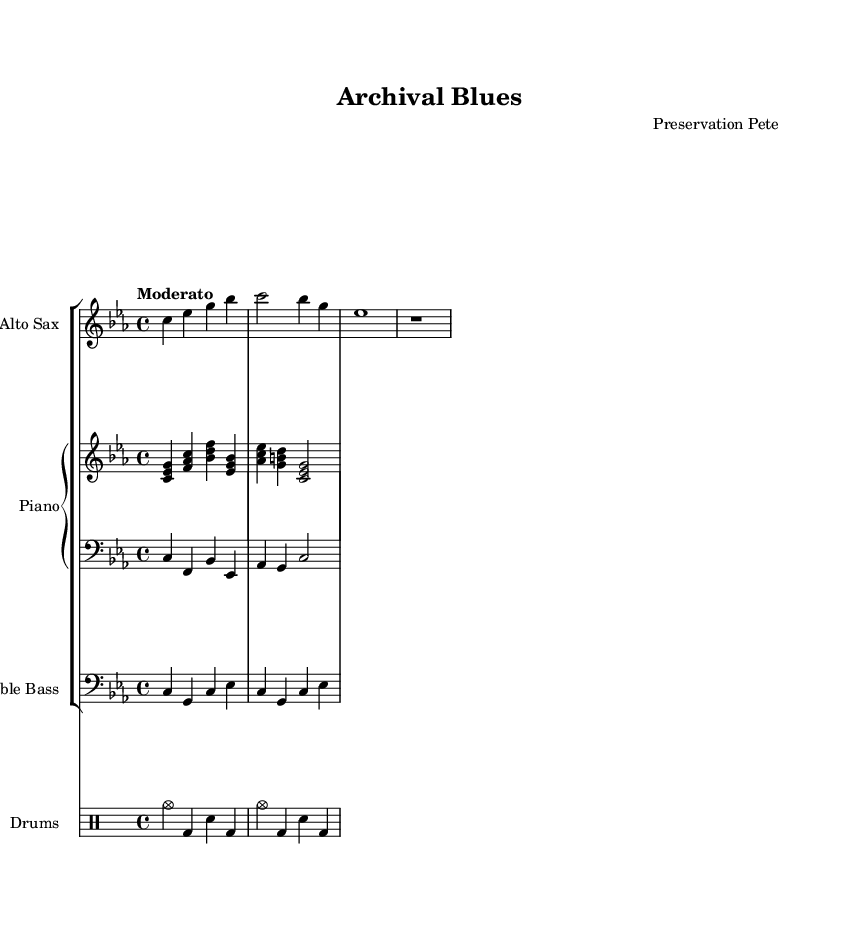What is the key signature of this music? The key signature is C minor, which includes three flats (B♭, E♭, A♭). You can identify the key signature at the beginning of the staff.
Answer: C minor What is the time signature of this composition? The time signature is 4/4, indicated at the beginning of the score, meaning there are four beats per measure.
Answer: 4/4 What is the tempo marking for this piece? The tempo marking is "Moderato," suggesting a moderate pace for the performance, which is typically around 108 to 120 beats per minute. This can be found in the header section of the score.
Answer: Moderato How many measures are in the saxophone part? The saxophone part contains four measures. You can count the measures in the staff from the beginning to the end of the saxophone music.
Answer: 4 Which instrument has a bass clef in this score? The instrument with a bass clef is the Double Bass, as indicated by the clef symbol at the beginning of its staff. This identifies it as a low-pitched instrument.
Answer: Double Bass What rhythmic figure is primarily used in the drum part? The drum part primarily uses a combination of cymbals and snare drum hits, with a repeated pattern indicating a swing or syncopated rhythm which is characteristic of jazz drumming.
Answer: Cymbals and snare What type of jazz does "Archival Blues" represent in its composition style? "Archival Blues" represents Cool Jazz, identifiable through its smooth, relaxed tempos and lighter tone, often featuring complex harmonies and subtle improvisation.
Answer: Cool Jazz 